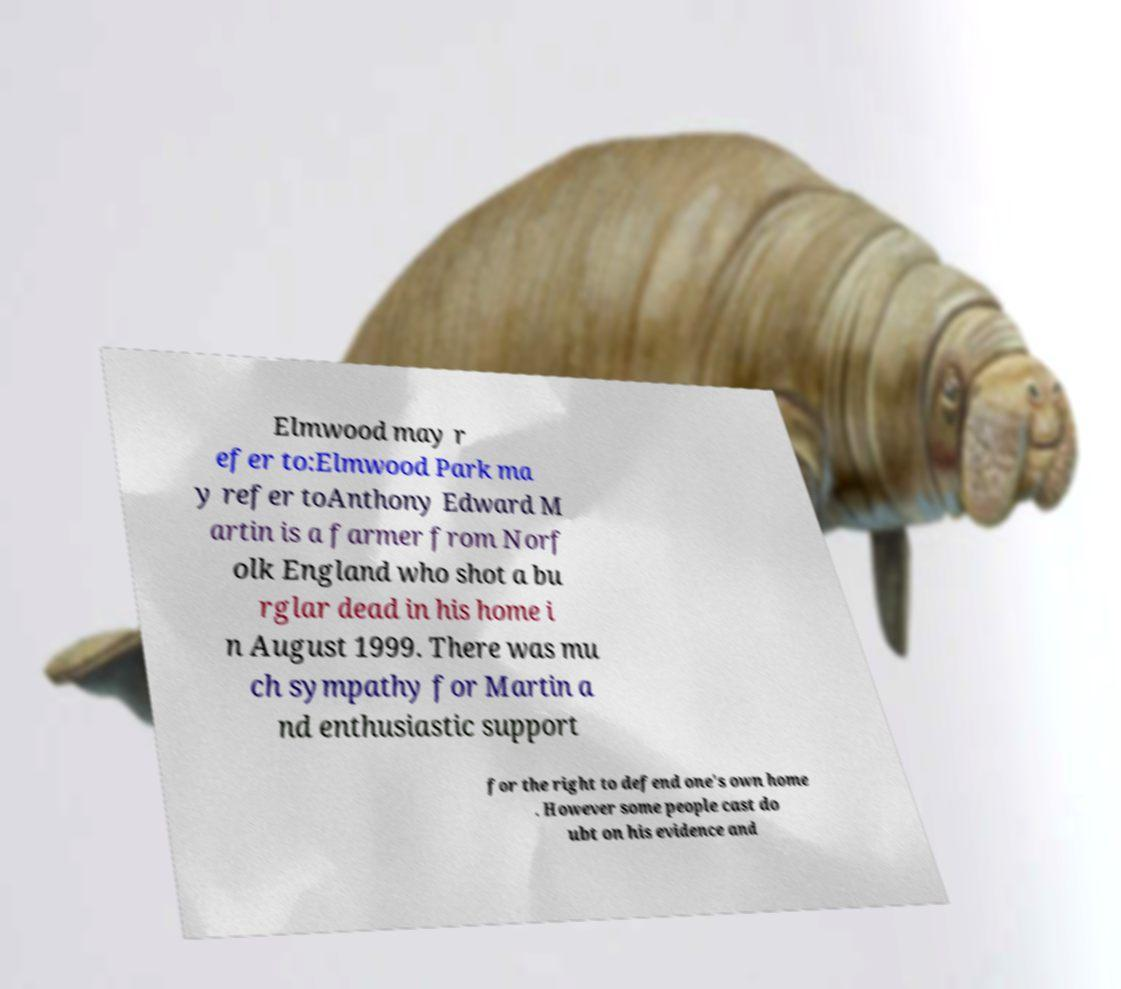Please identify and transcribe the text found in this image. Elmwood may r efer to:Elmwood Park ma y refer toAnthony Edward M artin is a farmer from Norf olk England who shot a bu rglar dead in his home i n August 1999. There was mu ch sympathy for Martin a nd enthusiastic support for the right to defend one's own home . However some people cast do ubt on his evidence and 